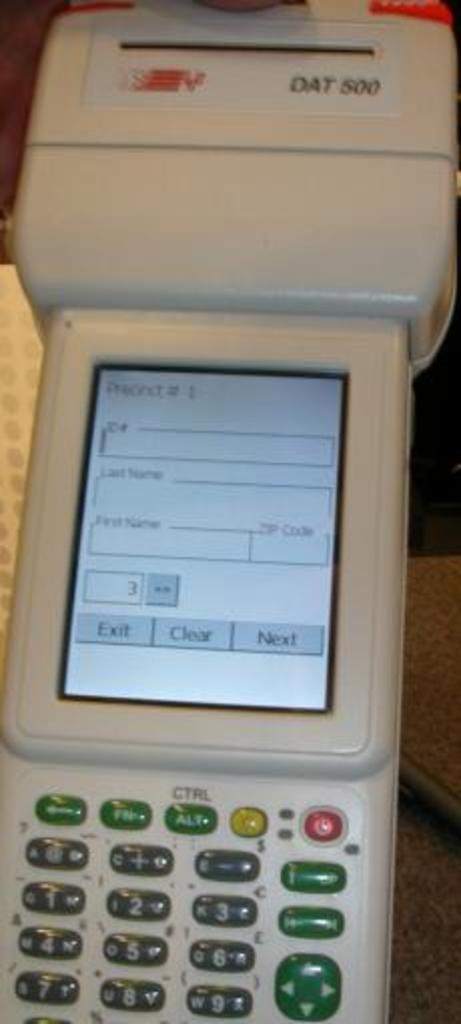<image>
Write a terse but informative summary of the picture. A piece of equipment called the DAT 500 has some green buttons on it. 